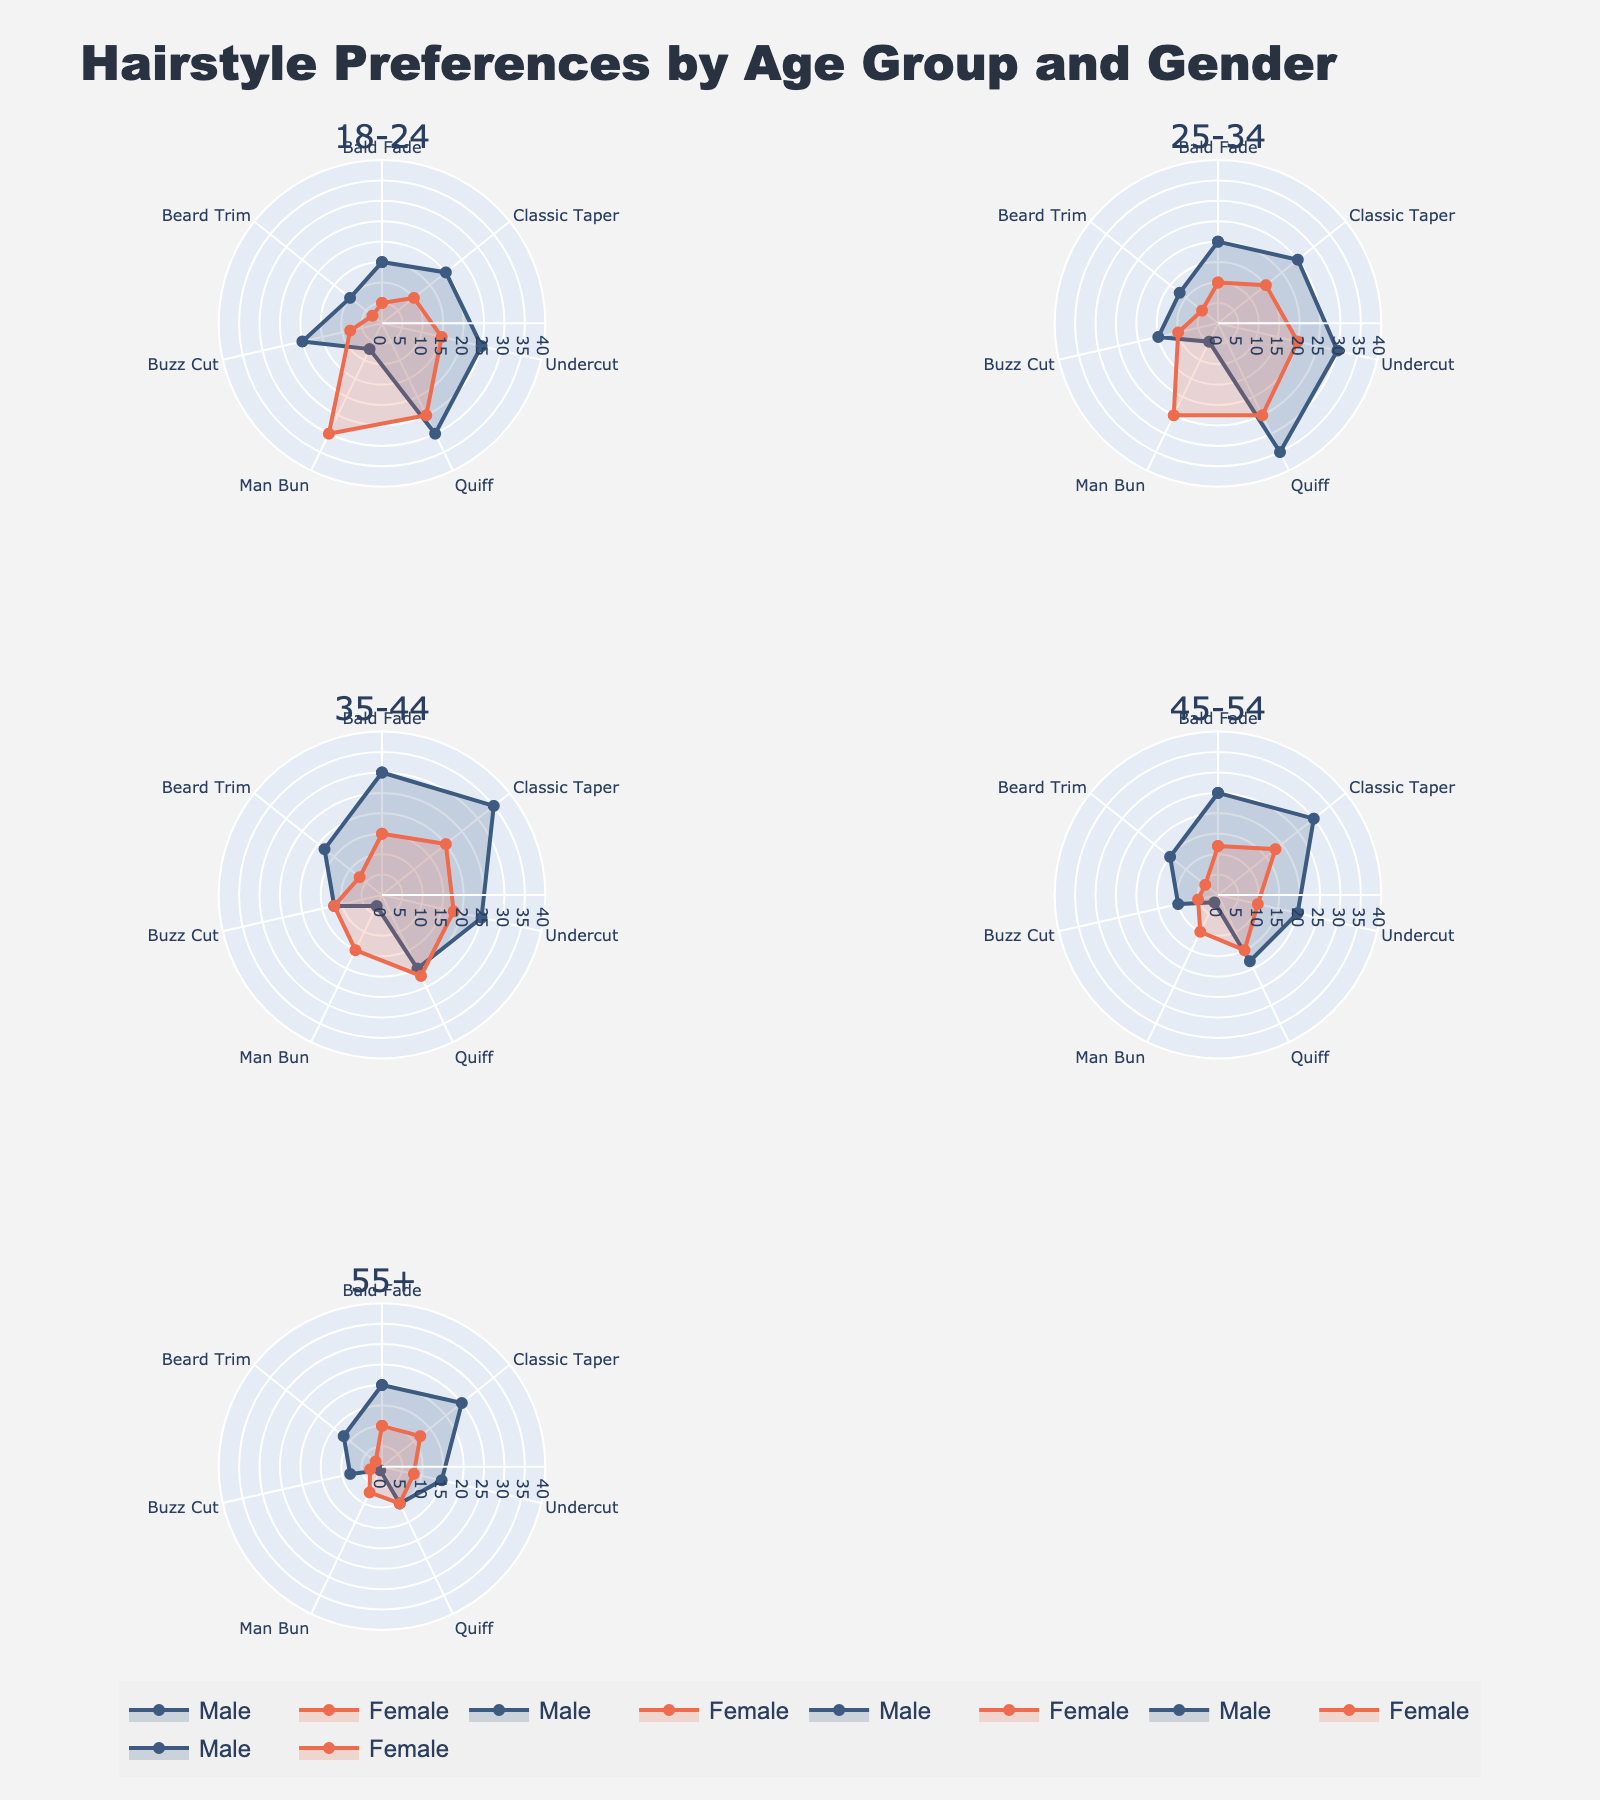Which age group has the highest preference for the Quiff hairstyle for males? From the radar chart, find the segment representing the Quiff for males in each age group and identify the one with the highest value. The 25-34 age group shows the highest preference value of 35.
Answer: 25-34 Between male and female in the 18-24 age group, who prefers the Man Bun hairstyle more? Compare the Man Bun segment for both males and females in the 18-24 age group. Females have a higher preference value of 30 compared to males' 7.
Answer: Female What is the total preference for Buzz Cut across all age groups for males? Sum the Buzz Cut values for males across all age groups. 20 (18-24) + 15 (25-34) + 12 (35-44) + 10 (45-54) + 8 (55+) = 65
Answer: 65 Which age group shows the least interest in Beard Trim for females? Locate the Beard Trim segment for females in each age group and identify the group with the lowest value. The 55+ age group shows the least interest with a value of 2.
Answer: 55+ Compare the preference for Undercut between 18-24 males and 45-54 females. Who prefers it more? Look at the Undercut values for 18-24 males and 45-54 females. The value for 18-24 males is 25, while for 45-54 females it is 10. The 18-24 males have a higher preference.
Answer: 18-24 males What is the general trend for the preference of the Bald Fade hairstyle as age increases for males? Examine the Bald Fade segments for males across increasing age groups. The values are 15 (18-24), 20 (25-34), 30 (35-44), 25 (45-54), and 20 (55+). The trend increases up to the 35-44 age group and then decreases.
Answer: Increases then decreases Is there a gender difference in the preference for the Classic Taper hairstyle in the 25-34 age group? Compare the Classic Taper values for males and females in the 25-34 age group. Males have a preference of 25 while females have 15. Males have a higher preference.
Answer: Yes, males prefer it more What's the average preference value for the Man Bun across all age groups for females? Sum the Man Bun values for females across all age groups and then divide by the number of age groups. The values are 30 (18-24), 25 (25-34), 15 (35-44), 10 (45-54), 7 (55+). The total is 87. The average is 87/5 = 17.4
Answer: 17.4 Which age group shows the most balanced preference between males and females for the Quiff hairstyle? Compare the Quiff preference values for males and females in each age group. The smallest difference occurs in the 35-44 age group with values 20 (males) and 22 (females), a difference of 2.
Answer: 35-44 Do males or females in the 35-44 age group have a higher total preference for all hairstyles combined? Sum the preference values for all hairstyles for both males and females in the 35-44 age group. Males: 30 + 35 + 25 + 20 + 3 + 12 + 18 = 143, Females: 15 + 20 + 18 + 22 + 15 + 12 + 7 = 109. Males have a higher total preference.
Answer: Males 